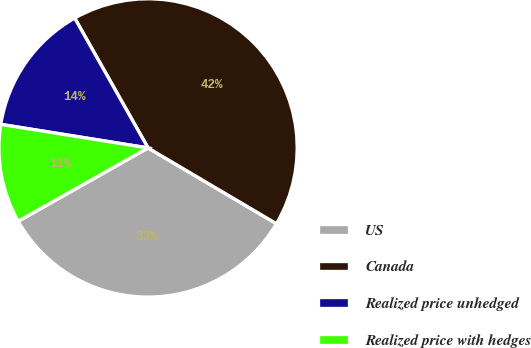Convert chart to OTSL. <chart><loc_0><loc_0><loc_500><loc_500><pie_chart><fcel>US<fcel>Canada<fcel>Realized price unhedged<fcel>Realized price with hedges<nl><fcel>33.33%<fcel>41.67%<fcel>14.29%<fcel>10.71%<nl></chart> 